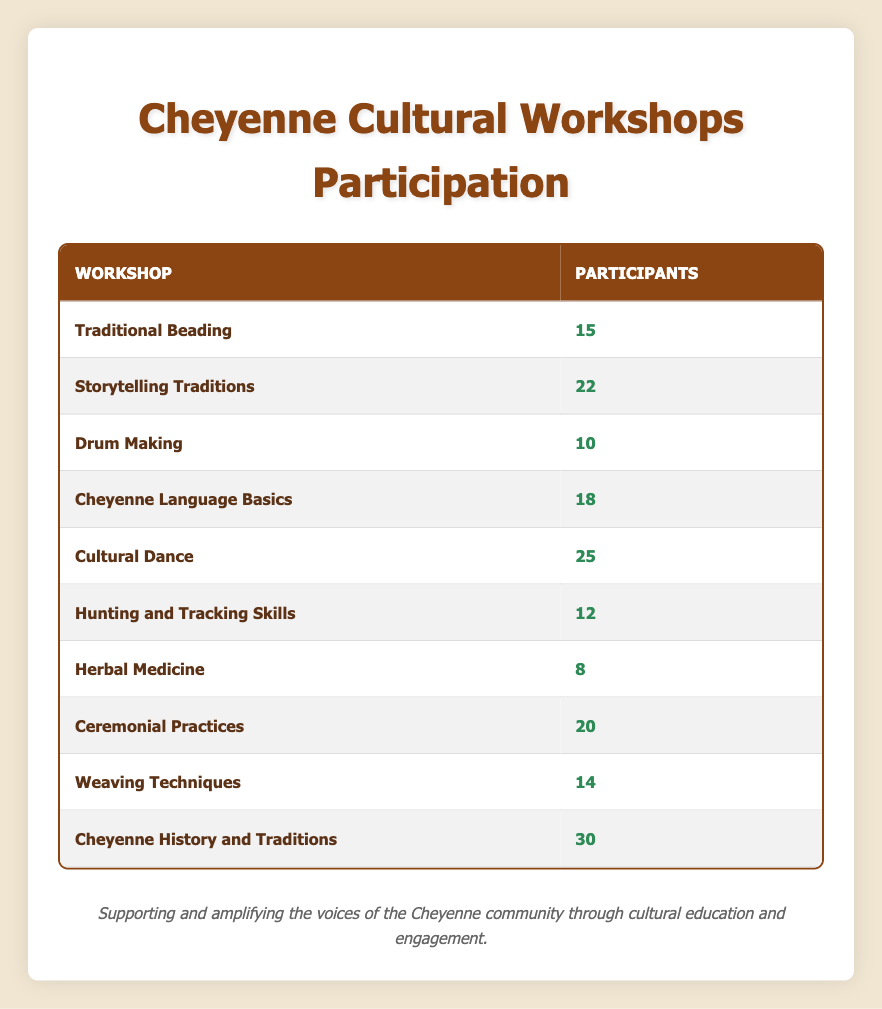What is the maximum number of participants in a single workshop? The participant counts for each workshop are listed. By examining the numbers, the maximum participant count is found in the workshop "Cheyenne History and Traditions," which has 30 participants.
Answer: 30 Which workshop has the least number of participants? The participant counts show various values; the smallest count belongs to the "Herbal Medicine" workshop with only 8 participants.
Answer: 8 How many participants are involved in Traditional Beading and Drum Making combined? To find the total, add the participants from both workshops: Traditional Beading has 15 participants and Drum Making has 10. Thus, 15 + 10 = 25 participants in total.
Answer: 25 Is the participation in Ceremonial Practices greater than in Cheyenne Language Basics? The table shows Ceremonial Practices with 20 participants and Cheyenne Language Basics with 18 participants. Since 20 is greater than 18, the answer is yes.
Answer: Yes What is the average number of participants across all workshops? To calculate the average, sum the participants from each workshop: 15 + 22 + 10 + 18 + 25 + 12 + 8 + 20 + 14 + 30 =  175. Since there are 10 workshops, divide 175 by 10, resulting in an average of 17.5 participants per workshop.
Answer: 17.5 How many workshops have more than 20 participants? By reviewing the participant counts, three workshops have more than 20 participants: Cultural Dance (25), Ceremonial Practices (20), and Cheyenne History and Traditions (30). Since Cultural Dance is the only one above 20, it can be concluded there is one workshop with more than 20 participants.
Answer: 1 What is the total number of participants for workshops with fewer than 15 participants? The workshops that meet this criterion are Drum Making (10), Herbal Medicine (8), and Hunting and Tracking Skills (12). Adding these gives 10 + 8 + 12 = 30 participants in total.
Answer: 30 Is Storytelling Traditions the only workshop with over 20 participants other than Cheyenne History and Traditions? Looking at the workshop participant counts, Storytelling Traditions has 22 participants, which is indeed over 20, and no other workshops besides Cheyenne History and Traditions exceed this count. Therefore, the answer is yes.
Answer: Yes 